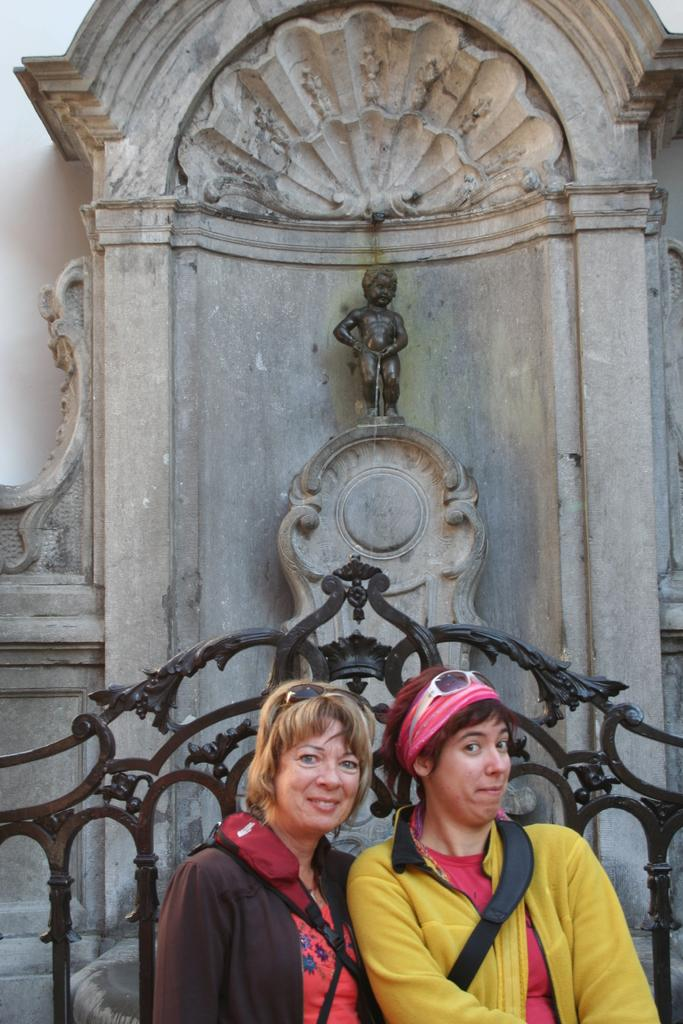How many women are in the image? There are two women in the image. What are the women wearing on their upper bodies? The women are wearing sweaters. What type of eyewear are the women wearing? The women are wearing glasses. What type of bags are the women carrying? The women are wearing backpacks. Where are the women standing in relation to the fence? The women are standing near a fence. What is the facial expression of the women in the image? The women are smiling. What can be seen in the background of the image? There is a child statue and a wall in the background of the image. What type of cord is being used to hold the gate open in the image? There is no gate or cord present in the image. What type of glass is being used to make the statue in the image? The image does not show the material used to make the statue; it only shows a child statue in the background. 